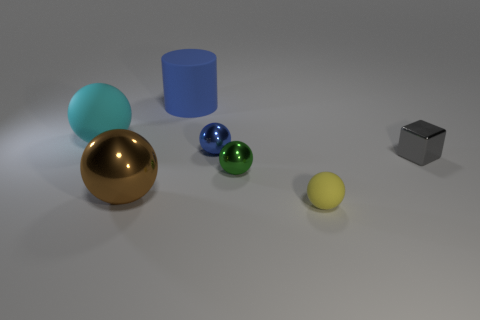How many tiny shiny things are the same color as the large cylinder?
Keep it short and to the point. 1. What material is the tiny sphere that is the same color as the cylinder?
Ensure brevity in your answer.  Metal. There is a green object that is the same shape as the tiny yellow rubber object; what is its size?
Your response must be concise. Small. Is there any other thing that is the same size as the brown sphere?
Your answer should be very brief. Yes. Does the brown metal thing have the same shape as the shiny thing that is on the right side of the green sphere?
Provide a succinct answer. No. The rubber object that is in front of the rubber thing that is left of the large sphere in front of the big cyan object is what color?
Provide a short and direct response. Yellow. What number of objects are either large spheres that are on the left side of the brown ball or big objects that are on the right side of the large brown shiny thing?
Offer a terse response. 2. What number of other objects are there of the same color as the cylinder?
Your answer should be very brief. 1. Do the tiny thing that is in front of the big shiny ball and the small green object have the same shape?
Provide a succinct answer. Yes. Is the number of large blue matte objects that are right of the metallic block less than the number of big red metal cylinders?
Offer a terse response. No. 